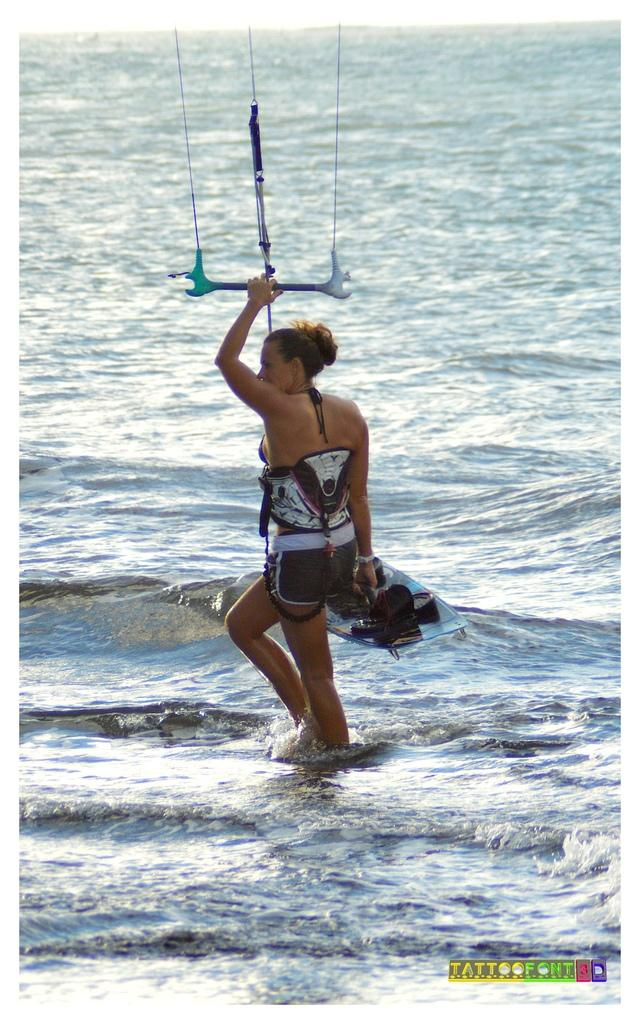Who is the main subject in the image? There is a woman in the image. What is the woman doing in the image? The woman is in water and holding a rod with strings attached. What else is the woman holding in the image? The woman is also holding a surfboard. What can be seen in the background of the image? The background of the image includes water with tides. What is the reaction of the ladybug when it sees the woman in the image? There is no ladybug present in the image, so it is not possible to determine its reaction. 